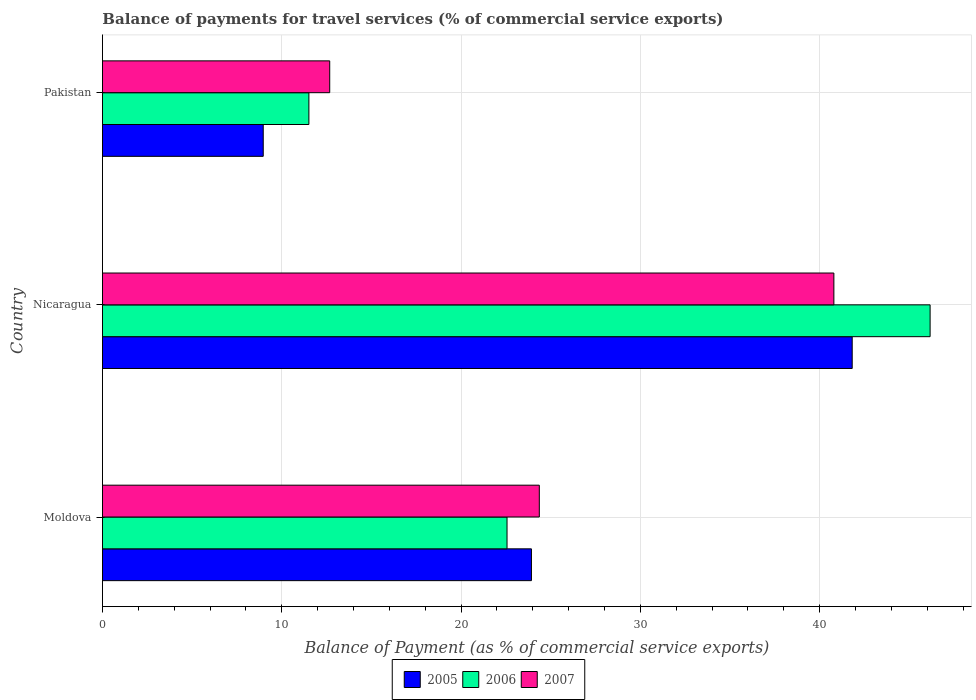How many groups of bars are there?
Keep it short and to the point. 3. Are the number of bars per tick equal to the number of legend labels?
Offer a terse response. Yes. What is the balance of payments for travel services in 2006 in Nicaragua?
Your answer should be compact. 46.16. Across all countries, what is the maximum balance of payments for travel services in 2007?
Your response must be concise. 40.79. Across all countries, what is the minimum balance of payments for travel services in 2005?
Offer a very short reply. 8.97. In which country was the balance of payments for travel services in 2007 maximum?
Make the answer very short. Nicaragua. What is the total balance of payments for travel services in 2005 in the graph?
Offer a very short reply. 74.7. What is the difference between the balance of payments for travel services in 2006 in Moldova and that in Pakistan?
Provide a succinct answer. 11.05. What is the difference between the balance of payments for travel services in 2006 in Nicaragua and the balance of payments for travel services in 2007 in Pakistan?
Offer a terse response. 33.48. What is the average balance of payments for travel services in 2006 per country?
Your response must be concise. 26.74. What is the difference between the balance of payments for travel services in 2006 and balance of payments for travel services in 2005 in Nicaragua?
Provide a short and direct response. 4.35. What is the ratio of the balance of payments for travel services in 2006 in Nicaragua to that in Pakistan?
Your answer should be very brief. 4.01. Is the balance of payments for travel services in 2007 in Moldova less than that in Pakistan?
Your answer should be compact. No. What is the difference between the highest and the second highest balance of payments for travel services in 2006?
Give a very brief answer. 23.59. What is the difference between the highest and the lowest balance of payments for travel services in 2007?
Provide a short and direct response. 28.12. In how many countries, is the balance of payments for travel services in 2006 greater than the average balance of payments for travel services in 2006 taken over all countries?
Offer a very short reply. 1. Is the sum of the balance of payments for travel services in 2005 in Moldova and Nicaragua greater than the maximum balance of payments for travel services in 2007 across all countries?
Offer a very short reply. Yes. What does the 3rd bar from the bottom in Moldova represents?
Offer a very short reply. 2007. Does the graph contain any zero values?
Make the answer very short. No. Does the graph contain grids?
Give a very brief answer. Yes. Where does the legend appear in the graph?
Ensure brevity in your answer.  Bottom center. How many legend labels are there?
Keep it short and to the point. 3. How are the legend labels stacked?
Your answer should be very brief. Horizontal. What is the title of the graph?
Ensure brevity in your answer.  Balance of payments for travel services (% of commercial service exports). What is the label or title of the X-axis?
Your response must be concise. Balance of Payment (as % of commercial service exports). What is the label or title of the Y-axis?
Give a very brief answer. Country. What is the Balance of Payment (as % of commercial service exports) in 2005 in Moldova?
Your answer should be compact. 23.92. What is the Balance of Payment (as % of commercial service exports) in 2006 in Moldova?
Your response must be concise. 22.56. What is the Balance of Payment (as % of commercial service exports) in 2007 in Moldova?
Provide a succinct answer. 24.36. What is the Balance of Payment (as % of commercial service exports) in 2005 in Nicaragua?
Provide a short and direct response. 41.81. What is the Balance of Payment (as % of commercial service exports) in 2006 in Nicaragua?
Ensure brevity in your answer.  46.16. What is the Balance of Payment (as % of commercial service exports) in 2007 in Nicaragua?
Give a very brief answer. 40.79. What is the Balance of Payment (as % of commercial service exports) in 2005 in Pakistan?
Keep it short and to the point. 8.97. What is the Balance of Payment (as % of commercial service exports) in 2006 in Pakistan?
Keep it short and to the point. 11.51. What is the Balance of Payment (as % of commercial service exports) of 2007 in Pakistan?
Keep it short and to the point. 12.67. Across all countries, what is the maximum Balance of Payment (as % of commercial service exports) in 2005?
Your response must be concise. 41.81. Across all countries, what is the maximum Balance of Payment (as % of commercial service exports) of 2006?
Give a very brief answer. 46.16. Across all countries, what is the maximum Balance of Payment (as % of commercial service exports) of 2007?
Provide a short and direct response. 40.79. Across all countries, what is the minimum Balance of Payment (as % of commercial service exports) of 2005?
Keep it short and to the point. 8.97. Across all countries, what is the minimum Balance of Payment (as % of commercial service exports) in 2006?
Your response must be concise. 11.51. Across all countries, what is the minimum Balance of Payment (as % of commercial service exports) of 2007?
Provide a short and direct response. 12.67. What is the total Balance of Payment (as % of commercial service exports) of 2005 in the graph?
Keep it short and to the point. 74.7. What is the total Balance of Payment (as % of commercial service exports) of 2006 in the graph?
Provide a succinct answer. 80.23. What is the total Balance of Payment (as % of commercial service exports) in 2007 in the graph?
Your response must be concise. 77.83. What is the difference between the Balance of Payment (as % of commercial service exports) in 2005 in Moldova and that in Nicaragua?
Provide a succinct answer. -17.89. What is the difference between the Balance of Payment (as % of commercial service exports) of 2006 in Moldova and that in Nicaragua?
Ensure brevity in your answer.  -23.59. What is the difference between the Balance of Payment (as % of commercial service exports) in 2007 in Moldova and that in Nicaragua?
Your answer should be compact. -16.43. What is the difference between the Balance of Payment (as % of commercial service exports) of 2005 in Moldova and that in Pakistan?
Your answer should be very brief. 14.96. What is the difference between the Balance of Payment (as % of commercial service exports) in 2006 in Moldova and that in Pakistan?
Offer a very short reply. 11.05. What is the difference between the Balance of Payment (as % of commercial service exports) of 2007 in Moldova and that in Pakistan?
Your answer should be compact. 11.69. What is the difference between the Balance of Payment (as % of commercial service exports) of 2005 in Nicaragua and that in Pakistan?
Ensure brevity in your answer.  32.85. What is the difference between the Balance of Payment (as % of commercial service exports) of 2006 in Nicaragua and that in Pakistan?
Give a very brief answer. 34.64. What is the difference between the Balance of Payment (as % of commercial service exports) of 2007 in Nicaragua and that in Pakistan?
Provide a short and direct response. 28.12. What is the difference between the Balance of Payment (as % of commercial service exports) in 2005 in Moldova and the Balance of Payment (as % of commercial service exports) in 2006 in Nicaragua?
Keep it short and to the point. -22.23. What is the difference between the Balance of Payment (as % of commercial service exports) of 2005 in Moldova and the Balance of Payment (as % of commercial service exports) of 2007 in Nicaragua?
Your response must be concise. -16.87. What is the difference between the Balance of Payment (as % of commercial service exports) in 2006 in Moldova and the Balance of Payment (as % of commercial service exports) in 2007 in Nicaragua?
Offer a very short reply. -18.23. What is the difference between the Balance of Payment (as % of commercial service exports) of 2005 in Moldova and the Balance of Payment (as % of commercial service exports) of 2006 in Pakistan?
Your answer should be compact. 12.41. What is the difference between the Balance of Payment (as % of commercial service exports) in 2005 in Moldova and the Balance of Payment (as % of commercial service exports) in 2007 in Pakistan?
Your answer should be compact. 11.25. What is the difference between the Balance of Payment (as % of commercial service exports) of 2006 in Moldova and the Balance of Payment (as % of commercial service exports) of 2007 in Pakistan?
Your answer should be compact. 9.89. What is the difference between the Balance of Payment (as % of commercial service exports) in 2005 in Nicaragua and the Balance of Payment (as % of commercial service exports) in 2006 in Pakistan?
Offer a terse response. 30.3. What is the difference between the Balance of Payment (as % of commercial service exports) of 2005 in Nicaragua and the Balance of Payment (as % of commercial service exports) of 2007 in Pakistan?
Make the answer very short. 29.14. What is the difference between the Balance of Payment (as % of commercial service exports) in 2006 in Nicaragua and the Balance of Payment (as % of commercial service exports) in 2007 in Pakistan?
Offer a very short reply. 33.48. What is the average Balance of Payment (as % of commercial service exports) in 2005 per country?
Make the answer very short. 24.9. What is the average Balance of Payment (as % of commercial service exports) in 2006 per country?
Make the answer very short. 26.74. What is the average Balance of Payment (as % of commercial service exports) in 2007 per country?
Provide a short and direct response. 25.94. What is the difference between the Balance of Payment (as % of commercial service exports) of 2005 and Balance of Payment (as % of commercial service exports) of 2006 in Moldova?
Your response must be concise. 1.36. What is the difference between the Balance of Payment (as % of commercial service exports) of 2005 and Balance of Payment (as % of commercial service exports) of 2007 in Moldova?
Offer a terse response. -0.44. What is the difference between the Balance of Payment (as % of commercial service exports) of 2006 and Balance of Payment (as % of commercial service exports) of 2007 in Moldova?
Provide a short and direct response. -1.8. What is the difference between the Balance of Payment (as % of commercial service exports) of 2005 and Balance of Payment (as % of commercial service exports) of 2006 in Nicaragua?
Provide a succinct answer. -4.34. What is the difference between the Balance of Payment (as % of commercial service exports) in 2006 and Balance of Payment (as % of commercial service exports) in 2007 in Nicaragua?
Provide a short and direct response. 5.37. What is the difference between the Balance of Payment (as % of commercial service exports) in 2005 and Balance of Payment (as % of commercial service exports) in 2006 in Pakistan?
Your response must be concise. -2.55. What is the difference between the Balance of Payment (as % of commercial service exports) of 2005 and Balance of Payment (as % of commercial service exports) of 2007 in Pakistan?
Keep it short and to the point. -3.71. What is the difference between the Balance of Payment (as % of commercial service exports) of 2006 and Balance of Payment (as % of commercial service exports) of 2007 in Pakistan?
Offer a very short reply. -1.16. What is the ratio of the Balance of Payment (as % of commercial service exports) of 2005 in Moldova to that in Nicaragua?
Keep it short and to the point. 0.57. What is the ratio of the Balance of Payment (as % of commercial service exports) of 2006 in Moldova to that in Nicaragua?
Offer a terse response. 0.49. What is the ratio of the Balance of Payment (as % of commercial service exports) of 2007 in Moldova to that in Nicaragua?
Give a very brief answer. 0.6. What is the ratio of the Balance of Payment (as % of commercial service exports) of 2005 in Moldova to that in Pakistan?
Your response must be concise. 2.67. What is the ratio of the Balance of Payment (as % of commercial service exports) in 2006 in Moldova to that in Pakistan?
Offer a terse response. 1.96. What is the ratio of the Balance of Payment (as % of commercial service exports) of 2007 in Moldova to that in Pakistan?
Your response must be concise. 1.92. What is the ratio of the Balance of Payment (as % of commercial service exports) in 2005 in Nicaragua to that in Pakistan?
Your answer should be compact. 4.66. What is the ratio of the Balance of Payment (as % of commercial service exports) of 2006 in Nicaragua to that in Pakistan?
Your response must be concise. 4.01. What is the ratio of the Balance of Payment (as % of commercial service exports) in 2007 in Nicaragua to that in Pakistan?
Make the answer very short. 3.22. What is the difference between the highest and the second highest Balance of Payment (as % of commercial service exports) of 2005?
Offer a very short reply. 17.89. What is the difference between the highest and the second highest Balance of Payment (as % of commercial service exports) in 2006?
Keep it short and to the point. 23.59. What is the difference between the highest and the second highest Balance of Payment (as % of commercial service exports) in 2007?
Your response must be concise. 16.43. What is the difference between the highest and the lowest Balance of Payment (as % of commercial service exports) in 2005?
Your response must be concise. 32.85. What is the difference between the highest and the lowest Balance of Payment (as % of commercial service exports) of 2006?
Keep it short and to the point. 34.64. What is the difference between the highest and the lowest Balance of Payment (as % of commercial service exports) in 2007?
Ensure brevity in your answer.  28.12. 